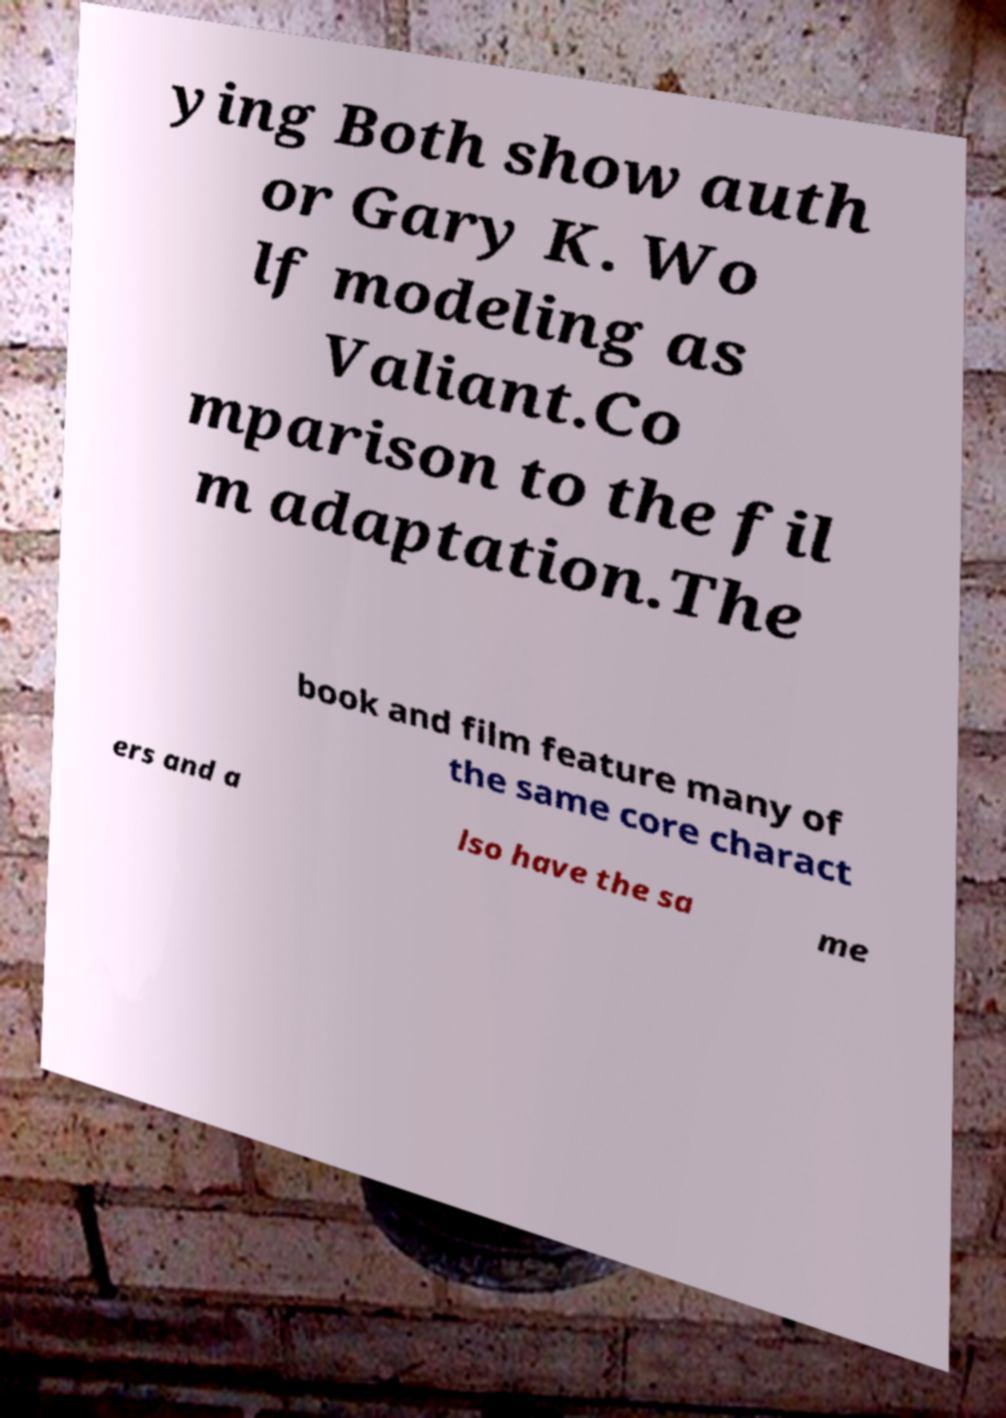Could you extract and type out the text from this image? ying Both show auth or Gary K. Wo lf modeling as Valiant.Co mparison to the fil m adaptation.The book and film feature many of the same core charact ers and a lso have the sa me 